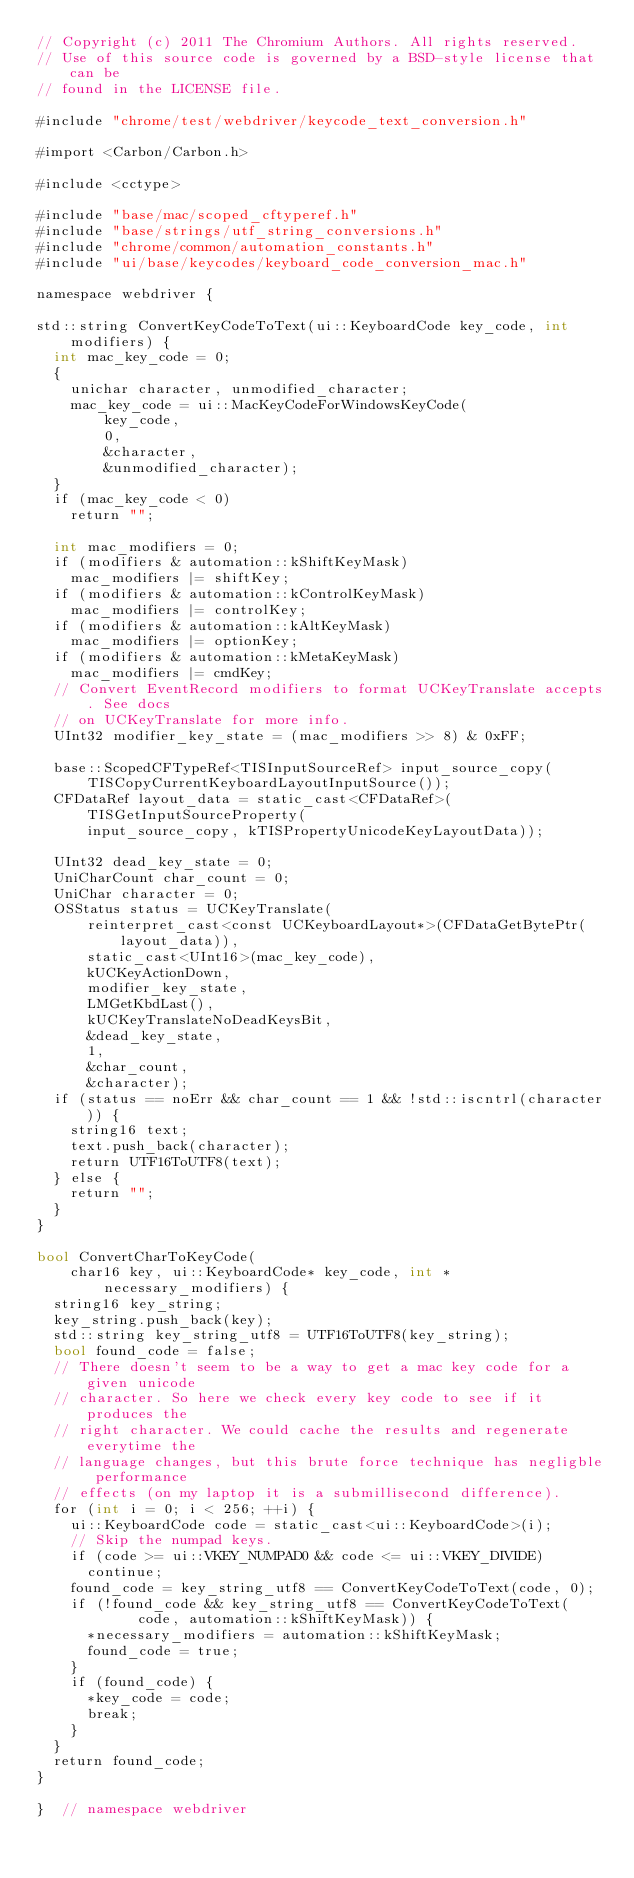<code> <loc_0><loc_0><loc_500><loc_500><_ObjectiveC_>// Copyright (c) 2011 The Chromium Authors. All rights reserved.
// Use of this source code is governed by a BSD-style license that can be
// found in the LICENSE file.

#include "chrome/test/webdriver/keycode_text_conversion.h"

#import <Carbon/Carbon.h>

#include <cctype>

#include "base/mac/scoped_cftyperef.h"
#include "base/strings/utf_string_conversions.h"
#include "chrome/common/automation_constants.h"
#include "ui/base/keycodes/keyboard_code_conversion_mac.h"

namespace webdriver {

std::string ConvertKeyCodeToText(ui::KeyboardCode key_code, int modifiers) {
  int mac_key_code = 0;
  {
    unichar character, unmodified_character;
    mac_key_code = ui::MacKeyCodeForWindowsKeyCode(
        key_code,
        0,
        &character,
        &unmodified_character);
  }
  if (mac_key_code < 0)
    return "";

  int mac_modifiers = 0;
  if (modifiers & automation::kShiftKeyMask)
    mac_modifiers |= shiftKey;
  if (modifiers & automation::kControlKeyMask)
    mac_modifiers |= controlKey;
  if (modifiers & automation::kAltKeyMask)
    mac_modifiers |= optionKey;
  if (modifiers & automation::kMetaKeyMask)
    mac_modifiers |= cmdKey;
  // Convert EventRecord modifiers to format UCKeyTranslate accepts. See docs
  // on UCKeyTranslate for more info.
  UInt32 modifier_key_state = (mac_modifiers >> 8) & 0xFF;

  base::ScopedCFTypeRef<TISInputSourceRef> input_source_copy(
      TISCopyCurrentKeyboardLayoutInputSource());
  CFDataRef layout_data = static_cast<CFDataRef>(TISGetInputSourceProperty(
      input_source_copy, kTISPropertyUnicodeKeyLayoutData));

  UInt32 dead_key_state = 0;
  UniCharCount char_count = 0;
  UniChar character = 0;
  OSStatus status = UCKeyTranslate(
      reinterpret_cast<const UCKeyboardLayout*>(CFDataGetBytePtr(layout_data)),
      static_cast<UInt16>(mac_key_code),
      kUCKeyActionDown,
      modifier_key_state,
      LMGetKbdLast(),
      kUCKeyTranslateNoDeadKeysBit,
      &dead_key_state,
      1,
      &char_count,
      &character);
  if (status == noErr && char_count == 1 && !std::iscntrl(character)) {
    string16 text;
    text.push_back(character);
    return UTF16ToUTF8(text);
  } else {
    return "";
  }
}

bool ConvertCharToKeyCode(
    char16 key, ui::KeyboardCode* key_code, int *necessary_modifiers) {
  string16 key_string;
  key_string.push_back(key);
  std::string key_string_utf8 = UTF16ToUTF8(key_string);
  bool found_code = false;
  // There doesn't seem to be a way to get a mac key code for a given unicode
  // character. So here we check every key code to see if it produces the
  // right character. We could cache the results and regenerate everytime the
  // language changes, but this brute force technique has negligble performance
  // effects (on my laptop it is a submillisecond difference).
  for (int i = 0; i < 256; ++i) {
    ui::KeyboardCode code = static_cast<ui::KeyboardCode>(i);
    // Skip the numpad keys.
    if (code >= ui::VKEY_NUMPAD0 && code <= ui::VKEY_DIVIDE)
      continue;
    found_code = key_string_utf8 == ConvertKeyCodeToText(code, 0);
    if (!found_code && key_string_utf8 == ConvertKeyCodeToText(
            code, automation::kShiftKeyMask)) {
      *necessary_modifiers = automation::kShiftKeyMask;
      found_code = true;
    }
    if (found_code) {
      *key_code = code;
      break;
    }
  }
  return found_code;
}

}  // namespace webdriver
</code> 